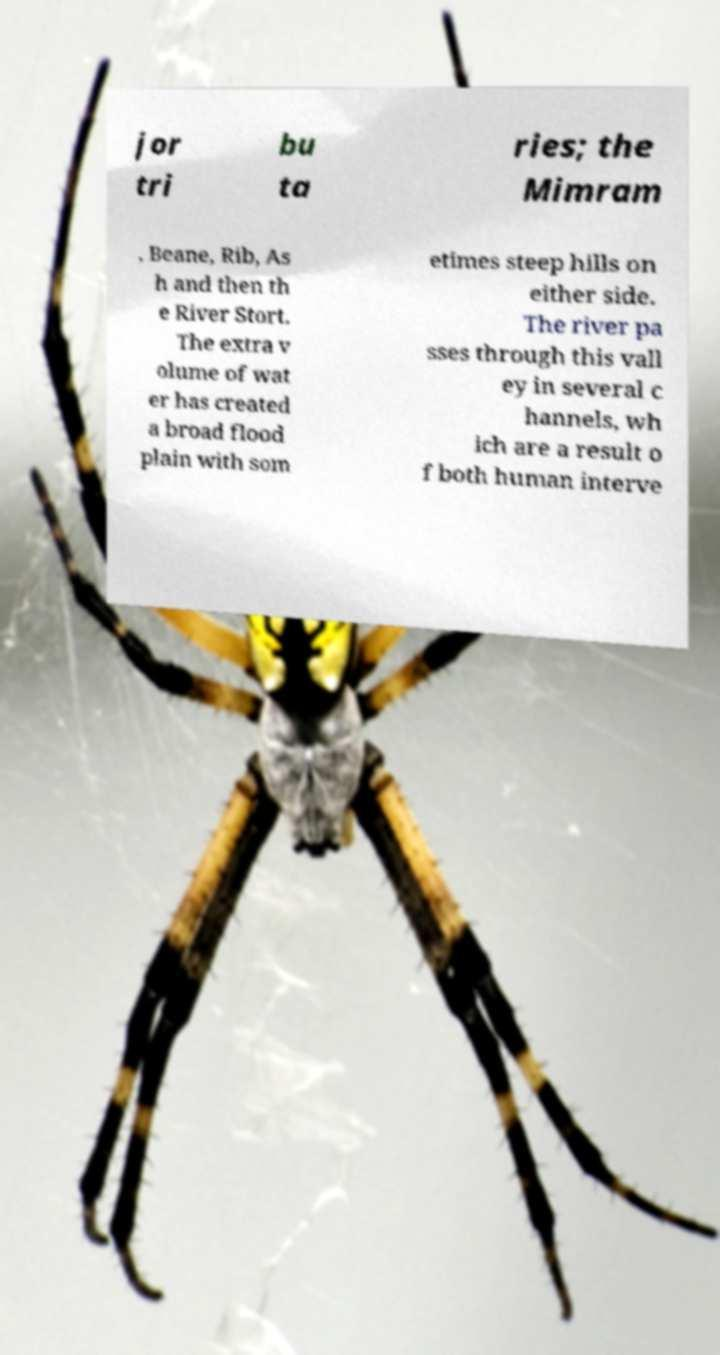There's text embedded in this image that I need extracted. Can you transcribe it verbatim? jor tri bu ta ries; the Mimram , Beane, Rib, As h and then th e River Stort. The extra v olume of wat er has created a broad flood plain with som etimes steep hills on either side. The river pa sses through this vall ey in several c hannels, wh ich are a result o f both human interve 